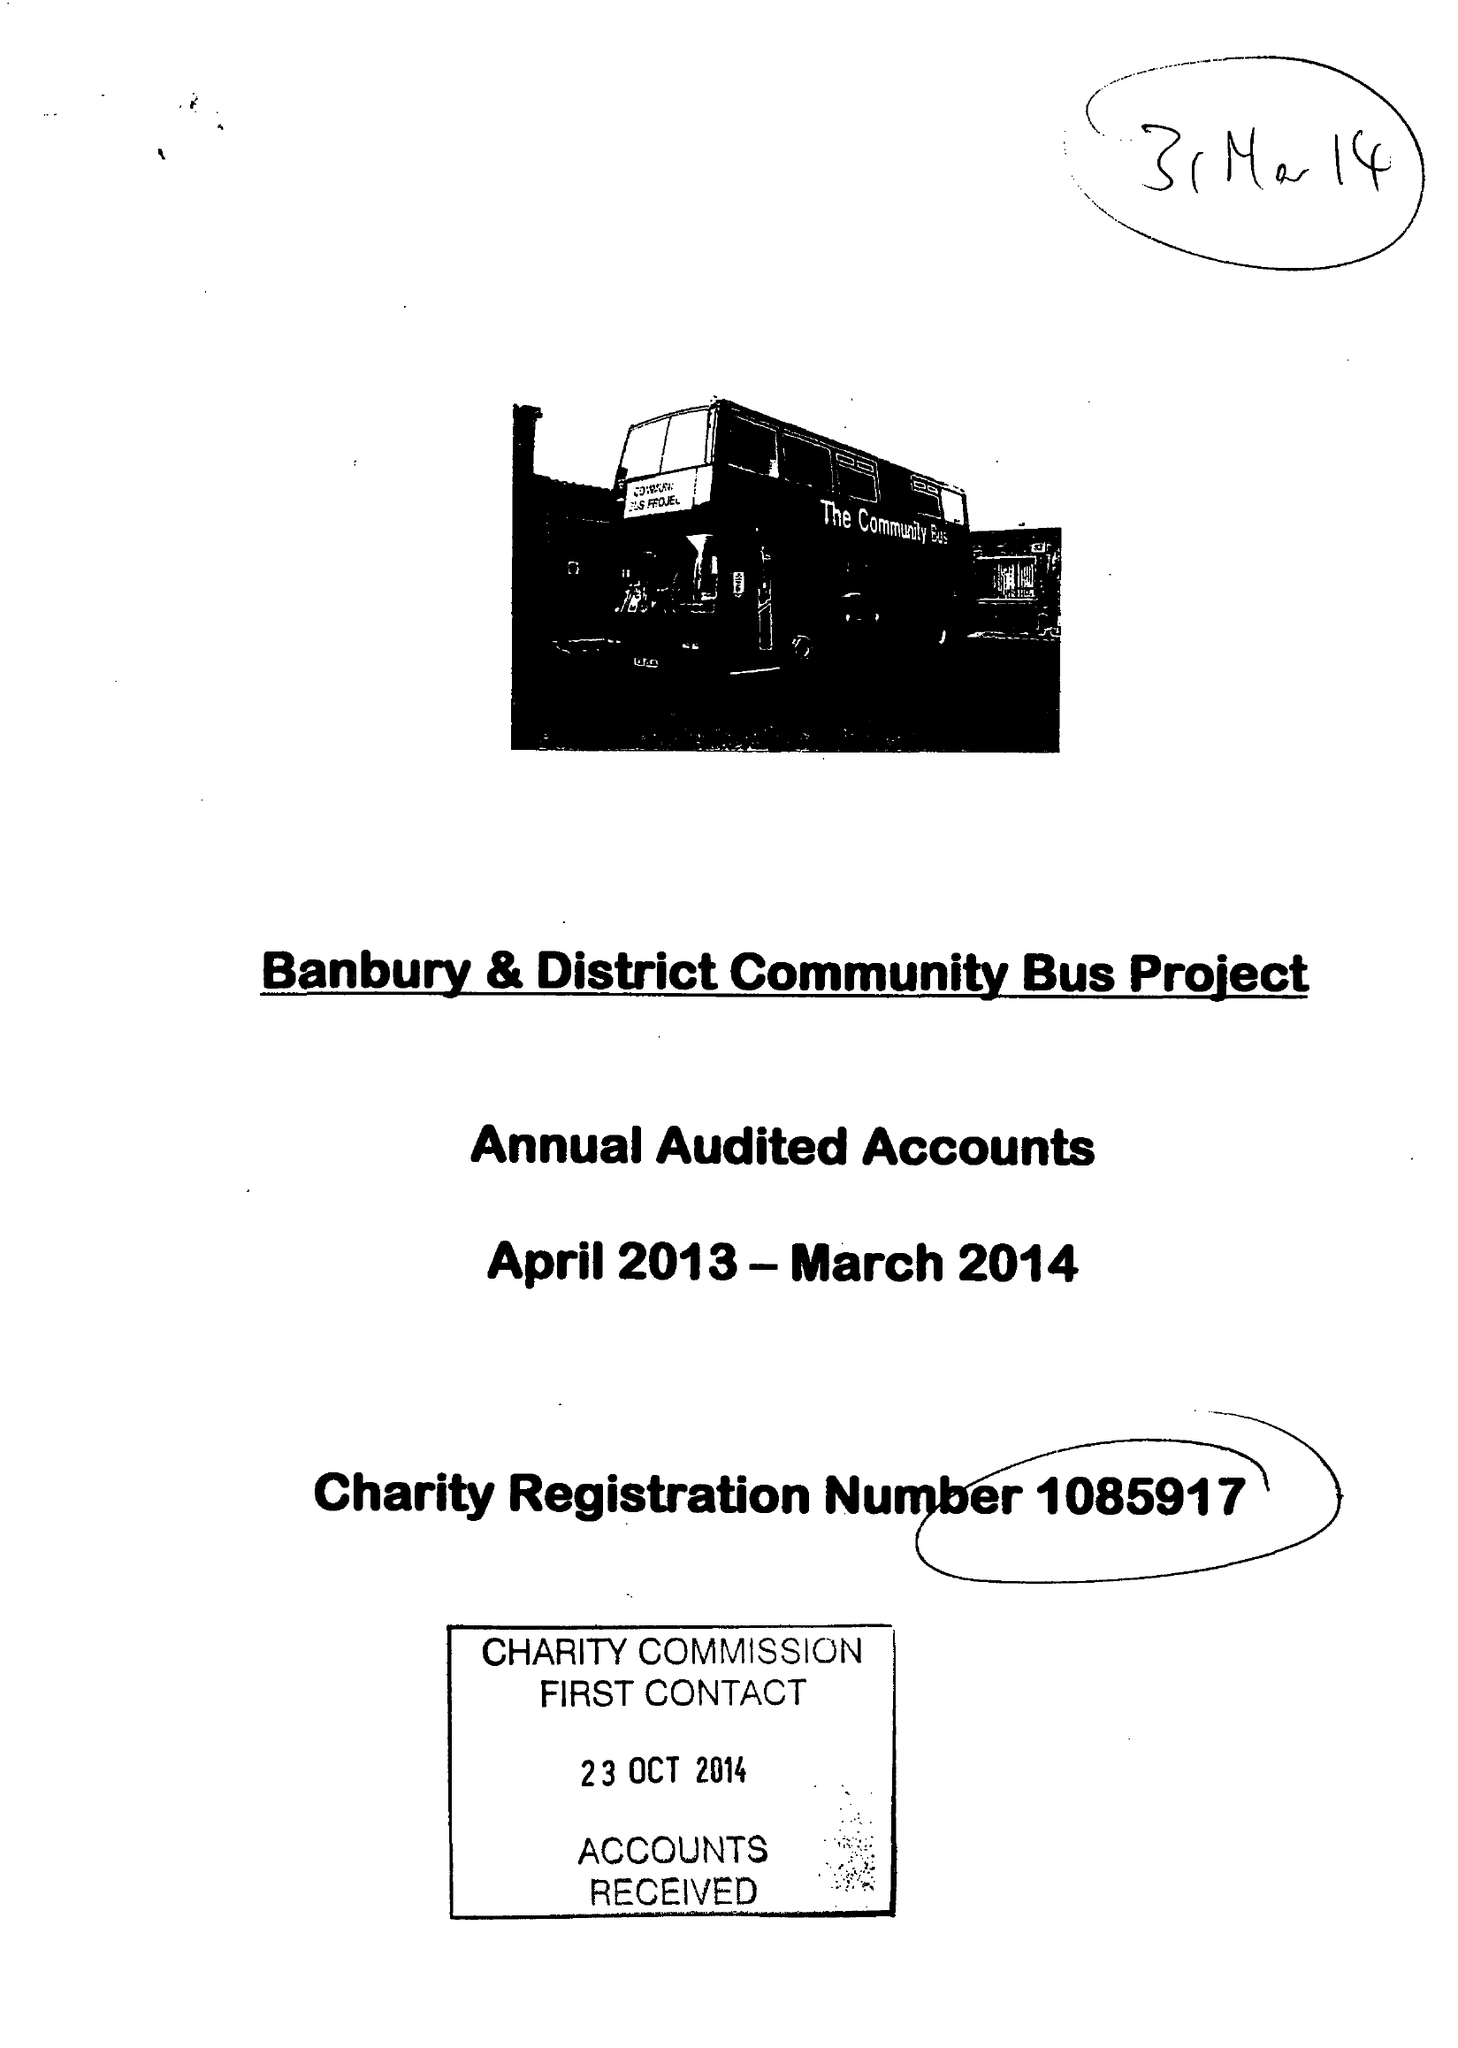What is the value for the income_annually_in_british_pounds?
Answer the question using a single word or phrase. 71126.00 